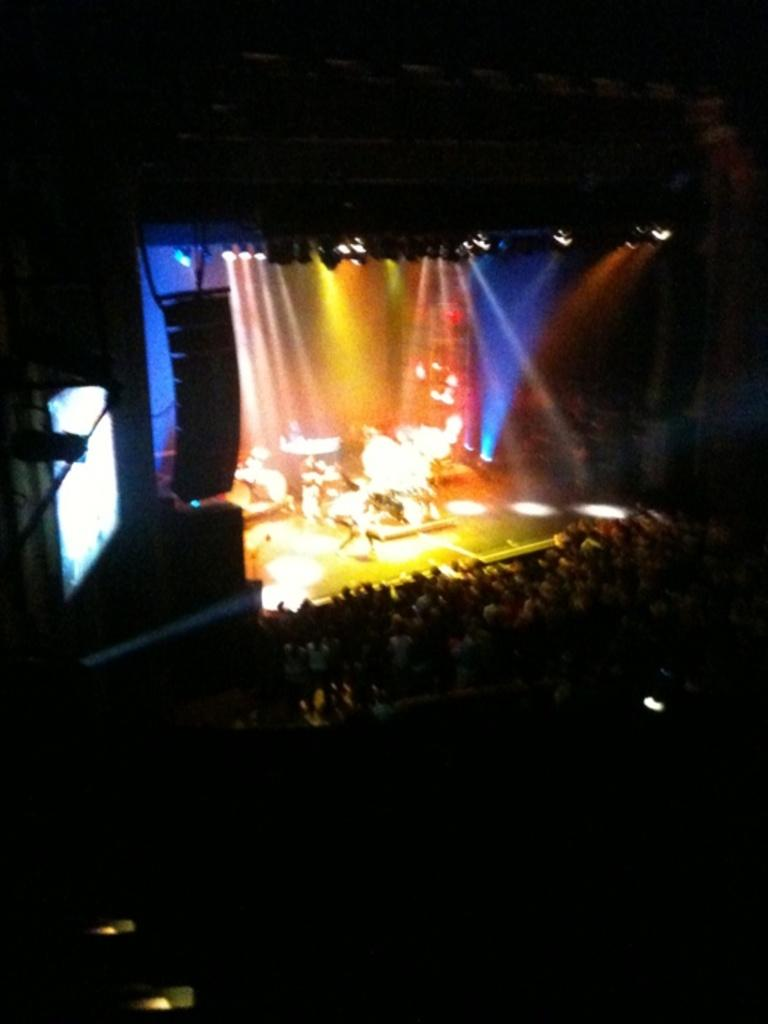What is the perspective of the image? The image is taken from a top angle. What is the main feature at the center of the image? There is a stage at the center of the image. What can be seen on the stage? There are instruments on the stage. Who is present in front of the stage? There are audience members in front of the stage. How would you describe the lighting in the image? The background of the image is dark. What type of wine is being served to the audience members in the image? There is no wine present in the image; it features a stage with instruments and an audience. Is there a baseball game happening in the image? No, there is no baseball game present in the image. 